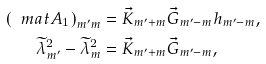Convert formula to latex. <formula><loc_0><loc_0><loc_500><loc_500>\left ( \ m a t { A } _ { 1 } \right ) _ { m ^ { \prime } m } & = \vec { K } _ { m ^ { \prime } + m } \vec { G } _ { m ^ { \prime } - m } h _ { m ^ { \prime } - m } , \\ \widetilde { \lambda } _ { m ^ { \prime } } ^ { 2 } - \widetilde { \lambda } _ { m } ^ { 2 } & = \vec { K } _ { m ^ { \prime } + m } \vec { G } _ { m ^ { \prime } - m } ,</formula> 